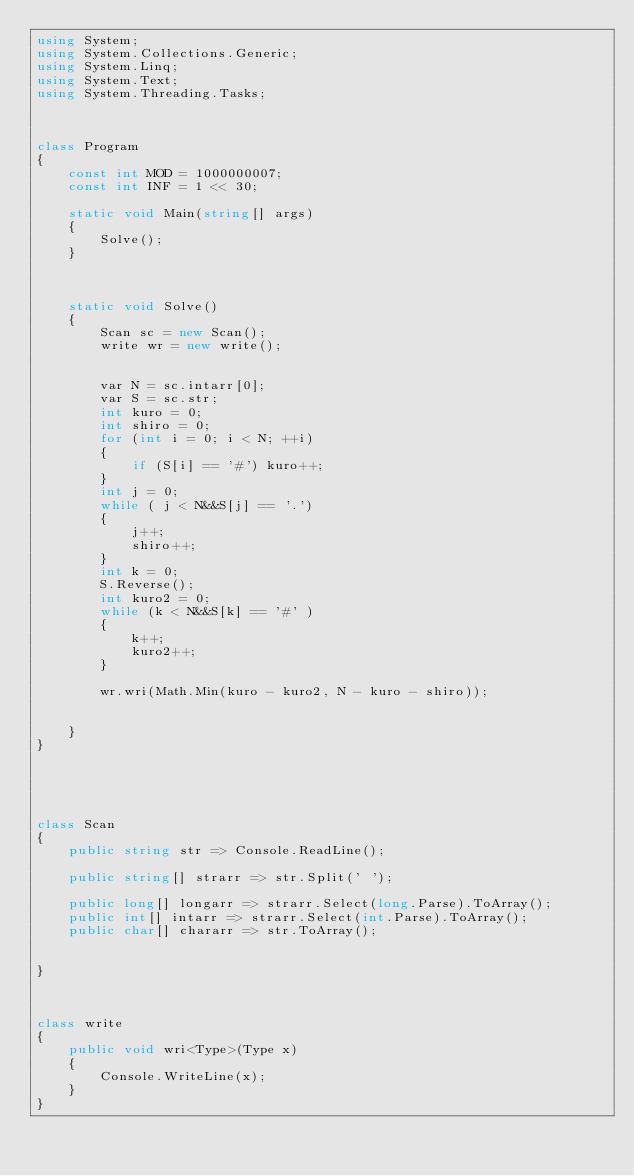<code> <loc_0><loc_0><loc_500><loc_500><_C#_>using System;
using System.Collections.Generic;
using System.Linq;
using System.Text;
using System.Threading.Tasks;



class Program
{
    const int MOD = 1000000007;
    const int INF = 1 << 30;

    static void Main(string[] args)
    {
        Solve();
    }



    static void Solve()
    {
        Scan sc = new Scan();
        write wr = new write();


        var N = sc.intarr[0];
        var S = sc.str;
        int kuro = 0;
        int shiro = 0;
        for (int i = 0; i < N; ++i)
        {
            if (S[i] == '#') kuro++;
        }
        int j = 0;
        while ( j < N&&S[j] == '.')
        {
            j++;
            shiro++;
        }
        int k = 0;
        S.Reverse();
        int kuro2 = 0;
        while (k < N&&S[k] == '#' )
        {
            k++;
            kuro2++;
        }

        wr.wri(Math.Min(kuro - kuro2, N - kuro - shiro));


    }
}





class Scan
{
    public string str => Console.ReadLine();

    public string[] strarr => str.Split(' ');

    public long[] longarr => strarr.Select(long.Parse).ToArray();
    public int[] intarr => strarr.Select(int.Parse).ToArray();
    public char[] chararr => str.ToArray();


}



class write
{
    public void wri<Type>(Type x)
    {
        Console.WriteLine(x);
    }
}
</code> 